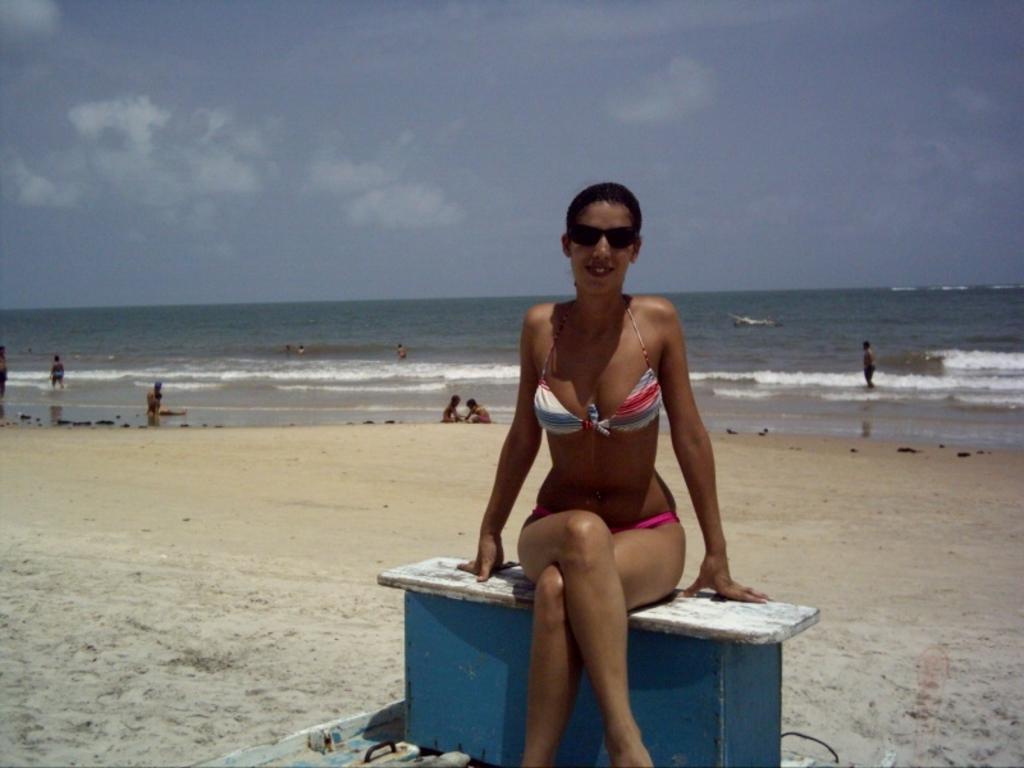Please provide a concise description of this image. In this picture we can see a woman wore goggles, smiling, sitting on a bench and at the back of her we can see some people, sand, water and in the background we can see the sky with clouds. 